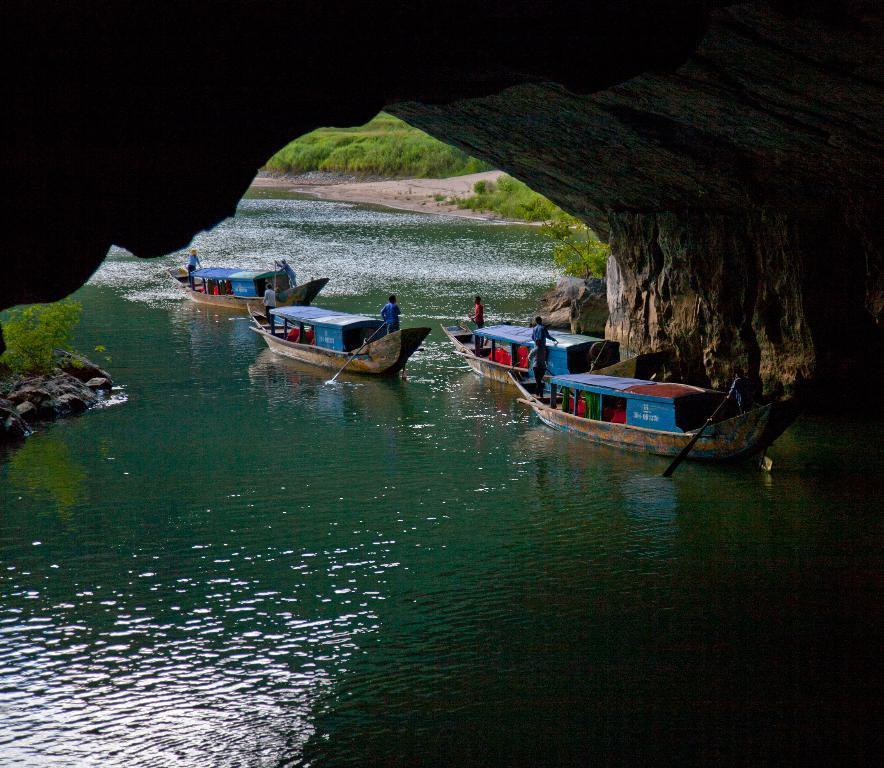How would you summarize this image in a sentence or two? At the top we can see a rock. At the bottom there is a water body. In the middle of the picture we can see boats, people, rocks and plants. In the background there are plants and sand. 